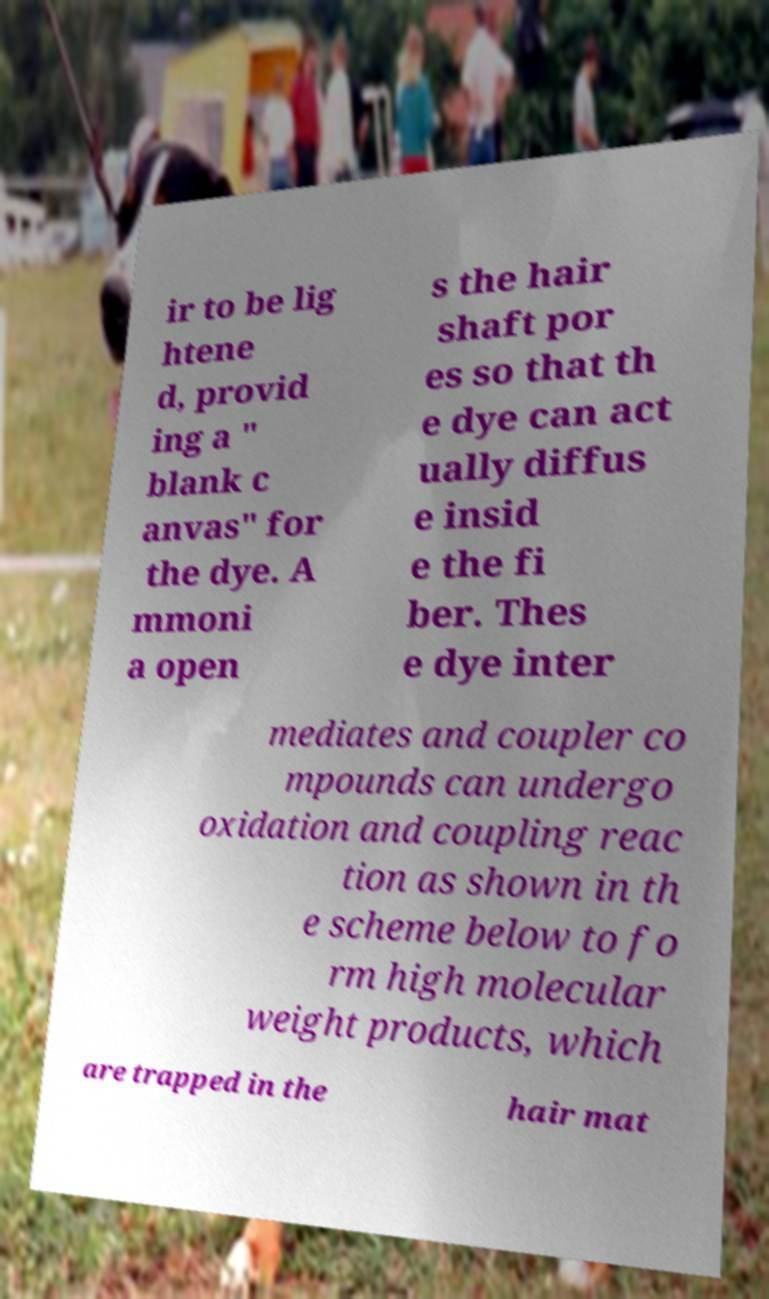For documentation purposes, I need the text within this image transcribed. Could you provide that? ir to be lig htene d, provid ing a " blank c anvas" for the dye. A mmoni a open s the hair shaft por es so that th e dye can act ually diffus e insid e the fi ber. Thes e dye inter mediates and coupler co mpounds can undergo oxidation and coupling reac tion as shown in th e scheme below to fo rm high molecular weight products, which are trapped in the hair mat 